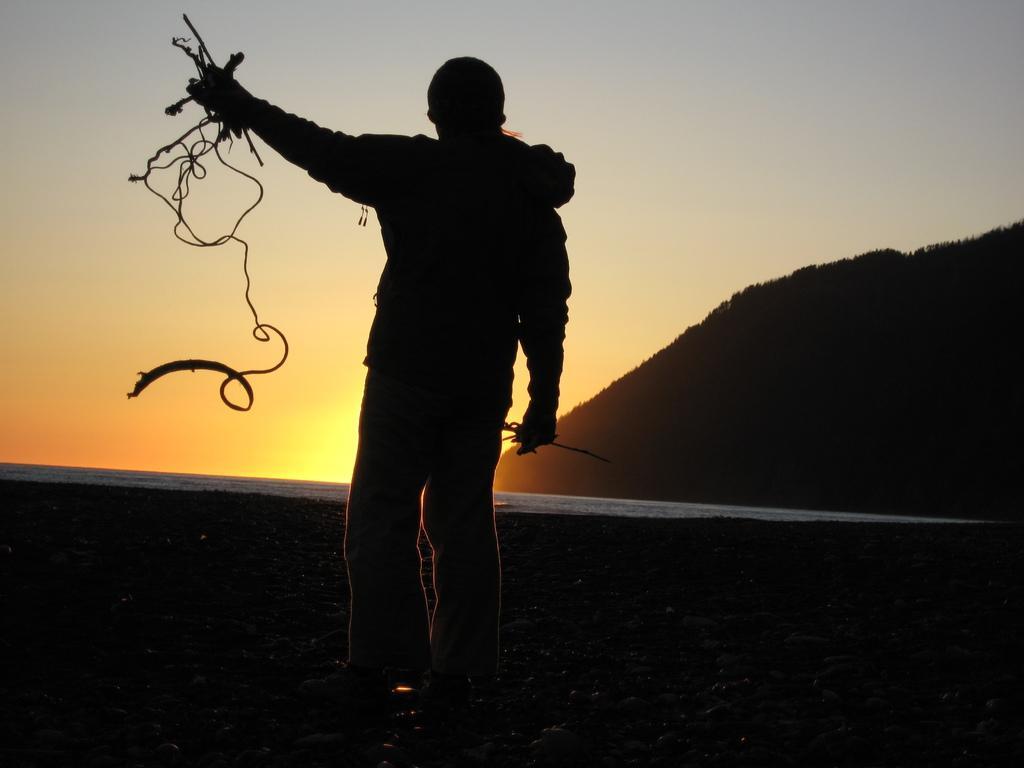Describe this image in one or two sentences. In this image there is a man standing, holding wires in his hand on a land, in the background there is water surface and a mountain and the sky. 